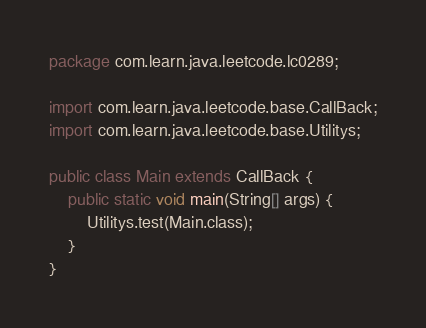Convert code to text. <code><loc_0><loc_0><loc_500><loc_500><_Java_>package com.learn.java.leetcode.lc0289;

import com.learn.java.leetcode.base.CallBack;
import com.learn.java.leetcode.base.Utilitys;

public class Main extends CallBack {
	public static void main(String[] args) {
		Utilitys.test(Main.class);
	}
}
</code> 